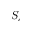<formula> <loc_0><loc_0><loc_500><loc_500>S _ { c }</formula> 